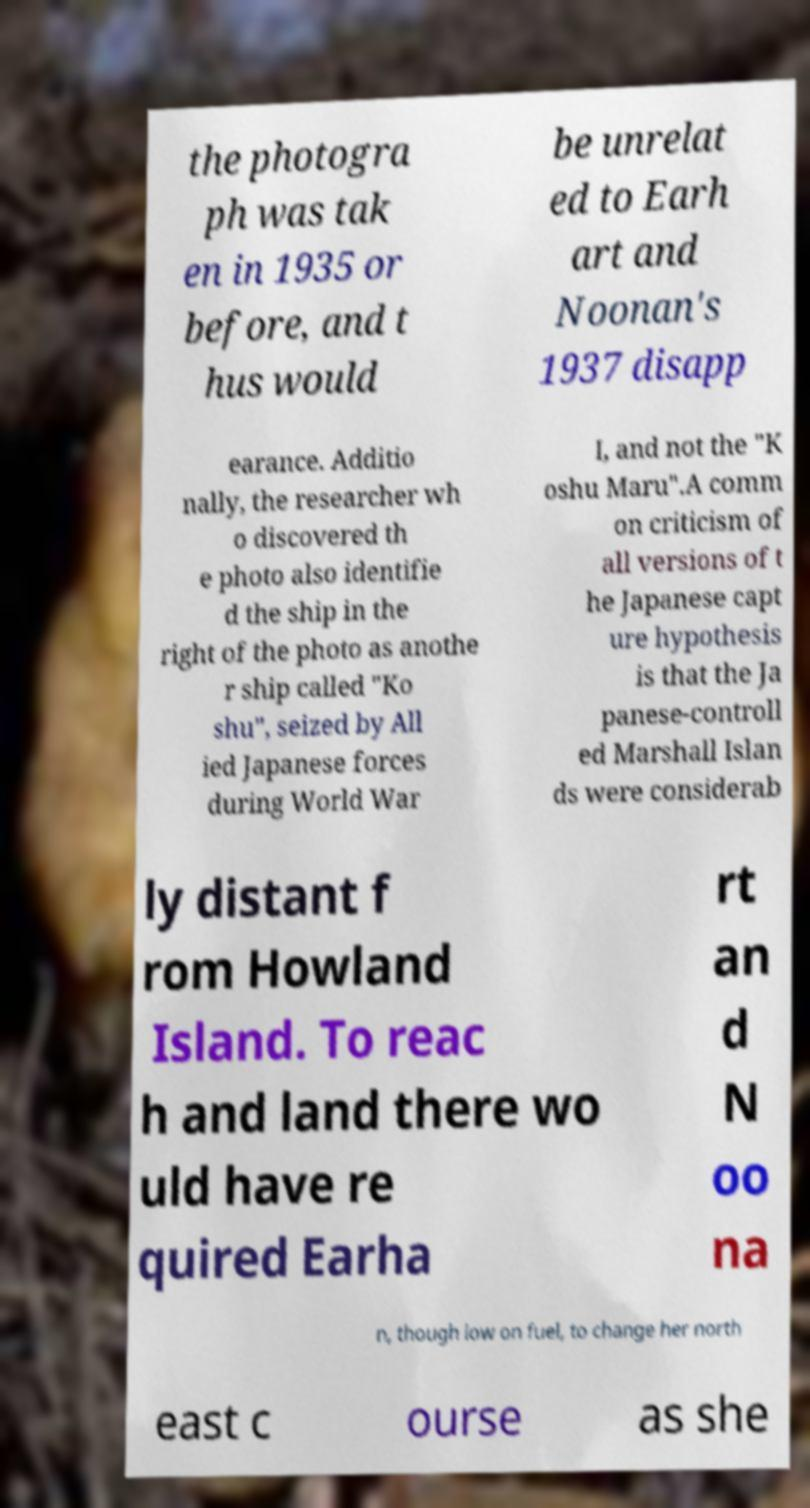What messages or text are displayed in this image? I need them in a readable, typed format. the photogra ph was tak en in 1935 or before, and t hus would be unrelat ed to Earh art and Noonan's 1937 disapp earance. Additio nally, the researcher wh o discovered th e photo also identifie d the ship in the right of the photo as anothe r ship called "Ko shu", seized by All ied Japanese forces during World War I, and not the "K oshu Maru".A comm on criticism of all versions of t he Japanese capt ure hypothesis is that the Ja panese-controll ed Marshall Islan ds were considerab ly distant f rom Howland Island. To reac h and land there wo uld have re quired Earha rt an d N oo na n, though low on fuel, to change her north east c ourse as she 